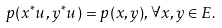Convert formula to latex. <formula><loc_0><loc_0><loc_500><loc_500>p ( x ^ { * } u , y ^ { * } u ) = p ( x , y ) , \forall x , y \in E .</formula> 